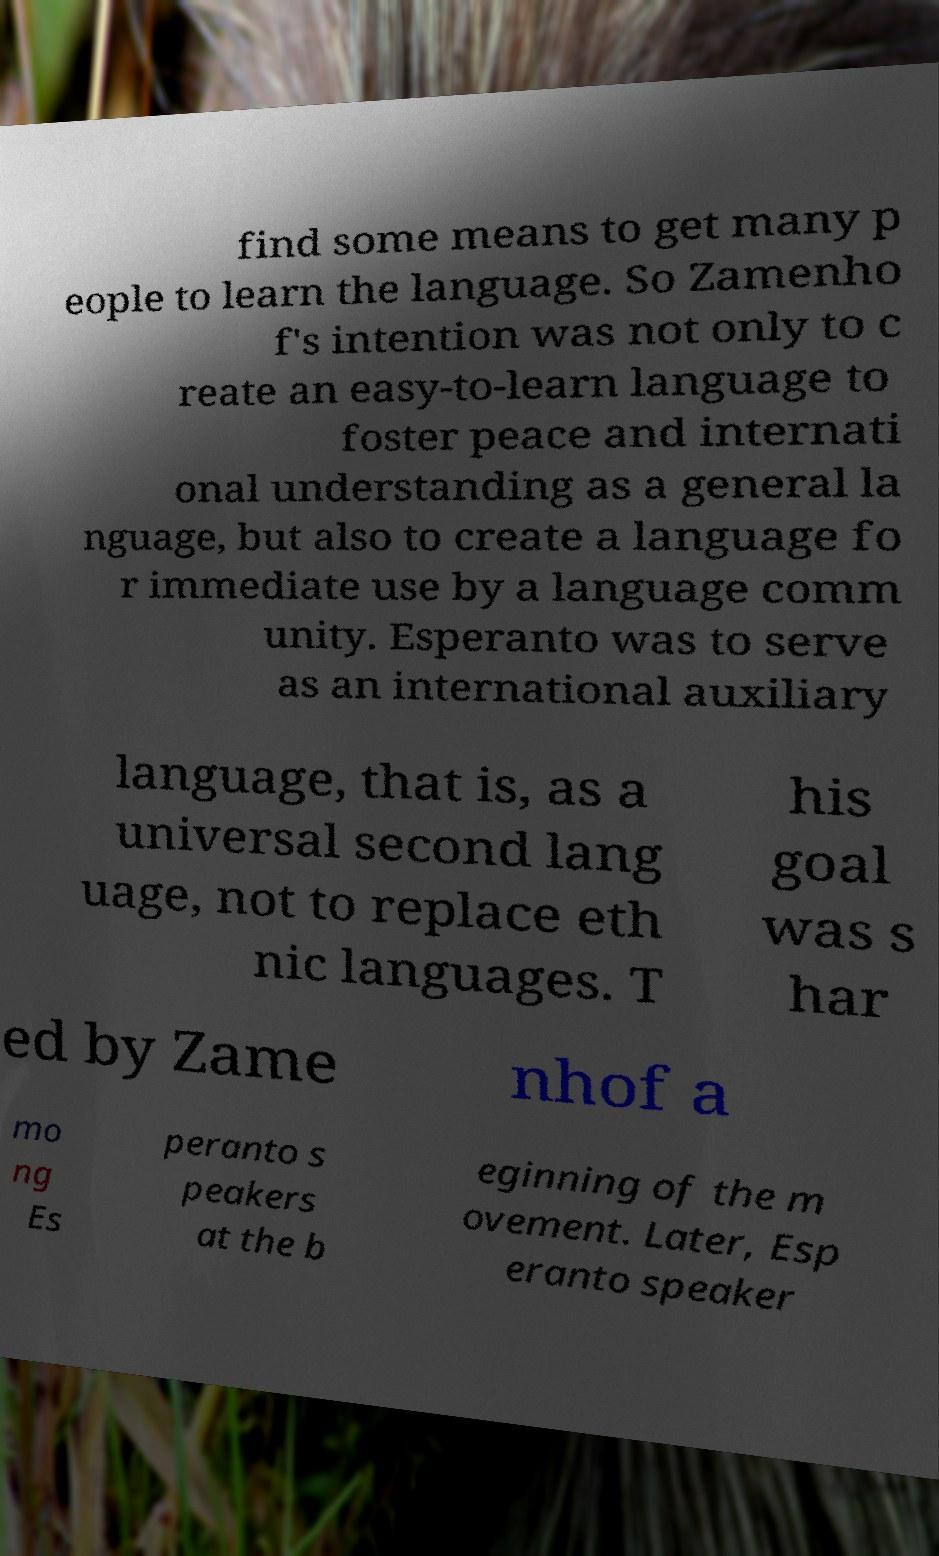Please read and relay the text visible in this image. What does it say? find some means to get many p eople to learn the language. So Zamenho f's intention was not only to c reate an easy-to-learn language to foster peace and internati onal understanding as a general la nguage, but also to create a language fo r immediate use by a language comm unity. Esperanto was to serve as an international auxiliary language, that is, as a universal second lang uage, not to replace eth nic languages. T his goal was s har ed by Zame nhof a mo ng Es peranto s peakers at the b eginning of the m ovement. Later, Esp eranto speaker 